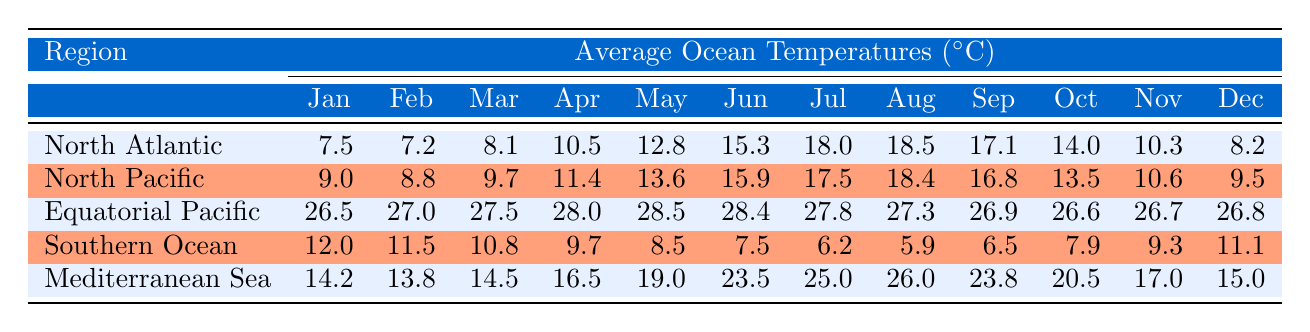What is the average ocean temperature in the North Atlantic for June? Referring to the table, the average ocean temperature in the North Atlantic for June is 15.3 degrees Celsius.
Answer: 15.3 What was the lowest temperature recorded in the Southern Ocean? The lowest temperature in the Southern Ocean occurs in July, which is 6.2 degrees Celsius.
Answer: 6.2 Which region experiences the highest average temperature in March? In March, the Equatorial Pacific has the highest average temperature at 27.5 degrees Celsius, compared to other regions.
Answer: 27.5 What is the difference between the highest and lowest temperature recorded in the Mediterranean Sea for the month of July? The highest temperature in the Mediterranean Sea in July is 25.0 degrees Celsius, and the lowest is 14.2 degrees Celsius in January. The difference is 25.0 - 14.2 = 10.8 degrees Celsius.
Answer: 10.8 Is the average ocean temperature in October higher in the North Atlantic than in the Southern Ocean? In October, the North Atlantic temperature is 14.0 degrees Celsius, while the Southern Ocean temperature is 7.9 degrees Celsius. Therefore, yes, the North Atlantic temperature is higher.
Answer: Yes What is the average temperature for the North Pacific over the months March to May? The temperatures for March, April, and May are 9.7, 11.4, and 13.6 degrees Celsius respectively. Summing them gives 9.7 + 11.4 + 13.6 = 34.7, and the average is 34.7 / 3 = 11.57 degrees Celsius.
Answer: 11.57 Which month shows the biggest temperature drop in the Southern Ocean from January to July? The temperature dropped from 12.0 degrees in January to 6.2 degrees in July, which is a decrease of 12.0 - 6.2 = 5.8 degrees Celsius. This is the biggest drop.
Answer: 5.8 How does the average temperature in the Equatorial Pacific compare to that of the North Atlantic in December? The average temperature in the Equatorial Pacific in December is 26.8 degrees Celsius, while in the North Atlantic, it is 8.2 degrees Celsius. Thus, the Equatorial Pacific is higher.
Answer: Higher Which region has the lowest average temperature across all months? The Southern Ocean consistently has lower temperatures across all months than other regions, peaking at 12.0 degrees in January and dropping to 5.9 degrees in August.
Answer: Southern Ocean 